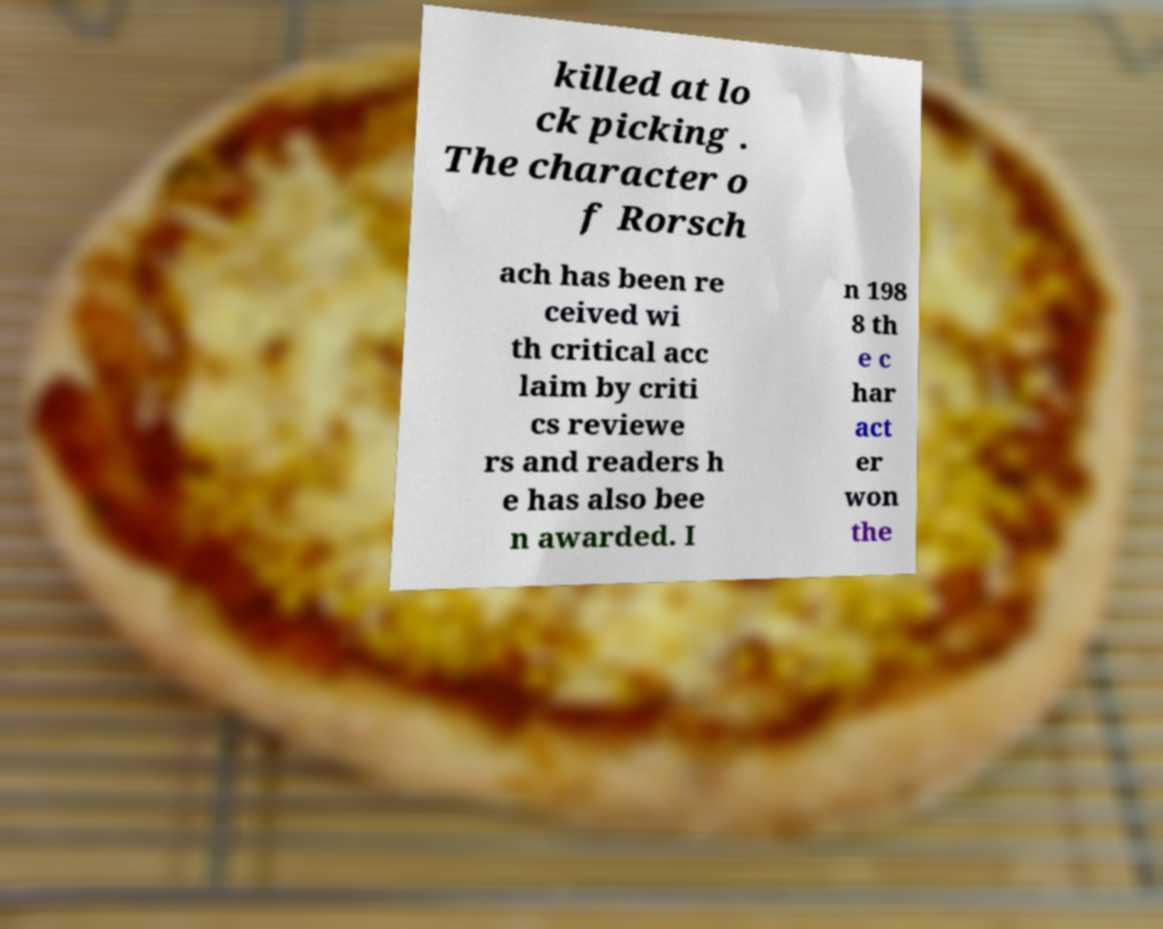Could you extract and type out the text from this image? killed at lo ck picking . The character o f Rorsch ach has been re ceived wi th critical acc laim by criti cs reviewe rs and readers h e has also bee n awarded. I n 198 8 th e c har act er won the 